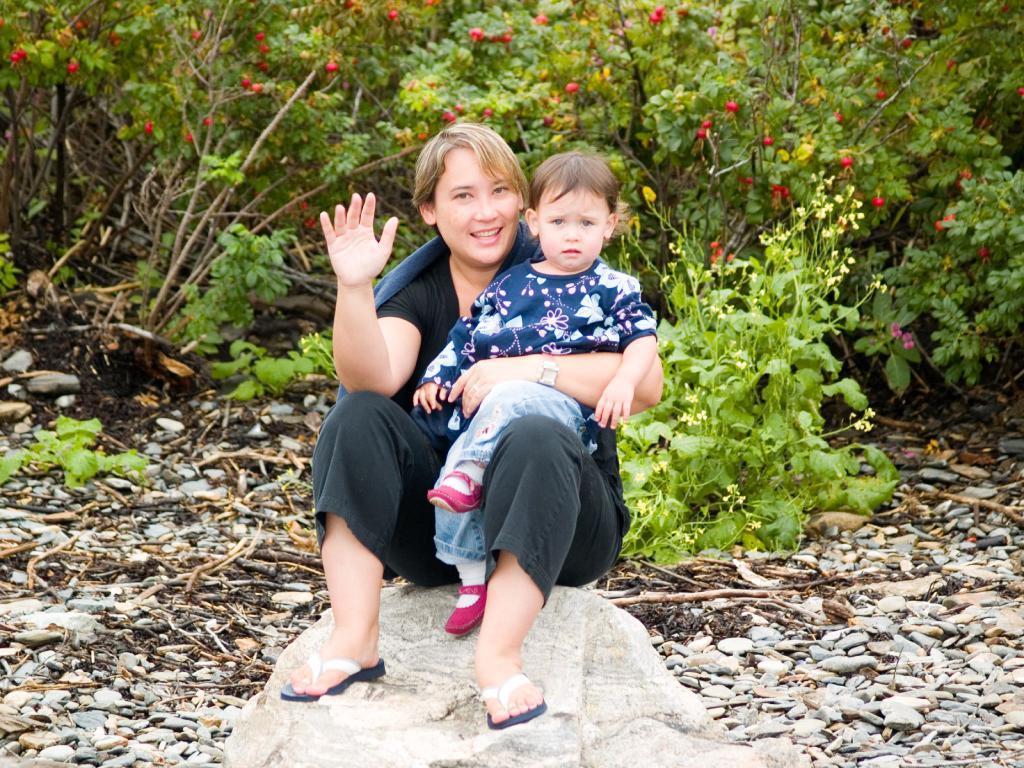How would you summarize this image in a sentence or two? In the center of the image we can see a woman sitting on the rock carrying a child. We can also see some stones, dried branches, a group of plants with fruits and flowers to it. 